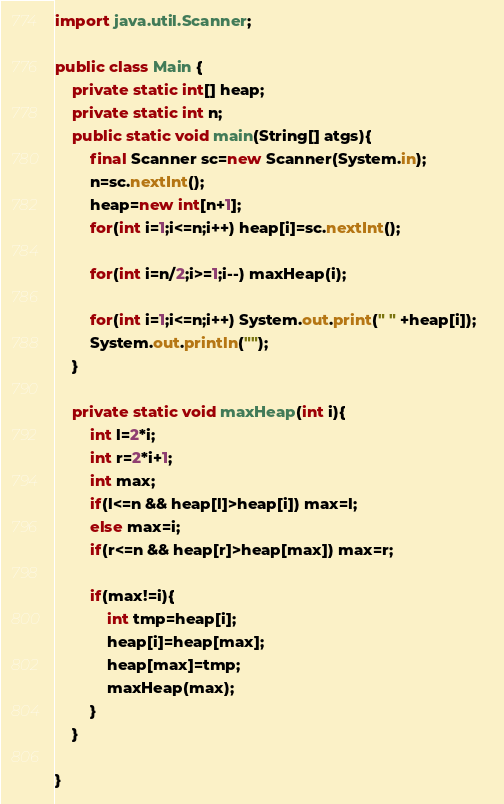Convert code to text. <code><loc_0><loc_0><loc_500><loc_500><_Java_>
import java.util.Scanner;

public class Main {
	private static int[] heap;
	private static int n;
	public static void main(String[] atgs){
		final Scanner sc=new Scanner(System.in);
		n=sc.nextInt();
		heap=new int[n+1];
		for(int i=1;i<=n;i++) heap[i]=sc.nextInt();
		
		for(int i=n/2;i>=1;i--) maxHeap(i);
		
		for(int i=1;i<=n;i++) System.out.print(" " +heap[i]);	
		System.out.println("");
	}
	
	private static void maxHeap(int i){
		int l=2*i;
		int r=2*i+1;
		int max;
		if(l<=n && heap[l]>heap[i]) max=l;
		else max=i;
		if(r<=n && heap[r]>heap[max]) max=r;
		
		if(max!=i){
			int tmp=heap[i];
			heap[i]=heap[max];
			heap[max]=tmp;
			maxHeap(max);
		}
	}

}</code> 